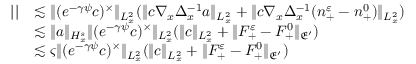Convert formula to latex. <formula><loc_0><loc_0><loc_500><loc_500>\begin{array} { r l } { | | } & { \lesssim \| ( e ^ { - \gamma \psi } c ) ^ { \times } \| _ { L _ { x } ^ { 2 } } ( \| c \nabla _ { x } \Delta _ { x } ^ { - 1 } a \| _ { L _ { x } ^ { 2 } } + \| c \nabla _ { x } \Delta _ { x } ^ { - 1 } ( n _ { + } ^ { \varepsilon } - n _ { + } ^ { 0 } ) \| _ { L _ { x } ^ { 2 } } ) } \\ & { \lesssim \| a \| _ { H _ { x } ^ { s } } \| ( e ^ { - \gamma \psi } c ) ^ { \times } \| _ { L _ { x } ^ { 2 } } ( \| c \| _ { L _ { x } ^ { 2 } } + \| F _ { + } ^ { \varepsilon } - F _ { + } ^ { 0 } \| _ { \mathfrak E ^ { \prime } } ) } \\ & { \lesssim \varsigma \| ( e ^ { - \gamma \psi } c ) ^ { \times } \| _ { L _ { x } ^ { 2 } } ( \| c \| _ { L _ { x } ^ { 2 } } + \| F _ { + } ^ { \varepsilon } - F _ { + } ^ { 0 } \| _ { \mathfrak E ^ { \prime } } ) } \end{array}</formula> 